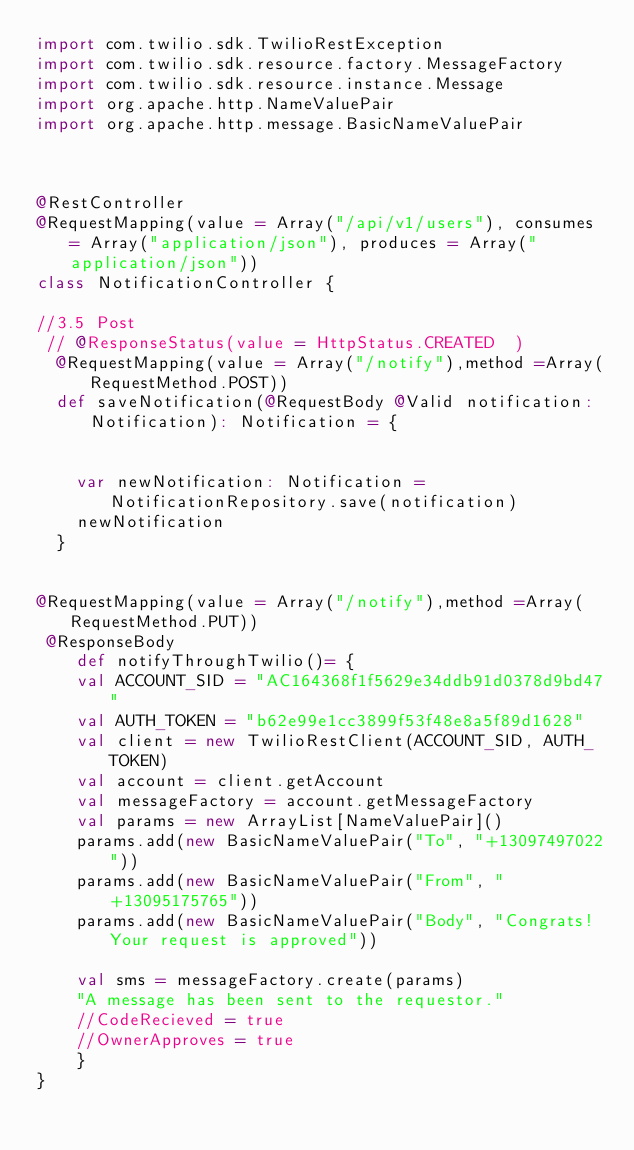Convert code to text. <code><loc_0><loc_0><loc_500><loc_500><_Scala_>import com.twilio.sdk.TwilioRestException 
import com.twilio.sdk.resource.factory.MessageFactory 
import com.twilio.sdk.resource.instance.Message 
import org.apache.http.NameValuePair 
import org.apache.http.message.BasicNameValuePair

    

@RestController 
@RequestMapping(value = Array("/api/v1/users"), consumes = Array("application/json"), produces = Array("application/json"))
class NotificationController {

//3.5 Post
 // @ResponseStatus(value = HttpStatus.CREATED  )
  @RequestMapping(value = Array("/notify"),method =Array(RequestMethod.POST))
  def saveNotification(@RequestBody @Valid notification: Notification): Notification = {

  	 
    var newNotification: Notification = NotificationRepository.save(notification)
    newNotification
  }
	  

@RequestMapping(value = Array("/notify"),method =Array(RequestMethod.PUT)) 
 @ResponseBody 
    def notifyThroughTwilio()= {  
    val ACCOUNT_SID = "AC164368f1f5629e34ddb91d0378d9bd47" 
    val AUTH_TOKEN = "b62e99e1cc3899f53f48e8a5f89d1628"   
    val client = new TwilioRestClient(ACCOUNT_SID, AUTH_TOKEN) 
    val account = client.getAccount 
    val messageFactory = account.getMessageFactory 
    val params = new ArrayList[NameValuePair]() 
    params.add(new BasicNameValuePair("To", "+13097497022")) 
    params.add(new BasicNameValuePair("From", "+13095175765"))
    params.add(new BasicNameValuePair("Body", "Congrats! Your request is approved"))
 
    val sms = messageFactory.create(params) 
    "A message has been sent to the requestor."
    //CodeRecieved = true
    //OwnerApproves = true
    }
}
</code> 